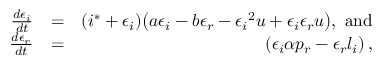<formula> <loc_0><loc_0><loc_500><loc_500>\begin{array} { r l r } { \frac { d \epsilon _ { i } } { d t } } & { = } & { ( i ^ { * } + \epsilon _ { i } ) \left ( a \epsilon _ { i } - b \epsilon _ { r } - { \epsilon _ { i } } ^ { 2 } u + \epsilon _ { i } \epsilon _ { r } u \right ) , a n d } \\ { \frac { d \epsilon _ { r } } { d t } } & { = } & { \left ( \epsilon _ { i } \alpha p _ { r } - \epsilon _ { r } l _ { i } \right ) , } \end{array}</formula> 